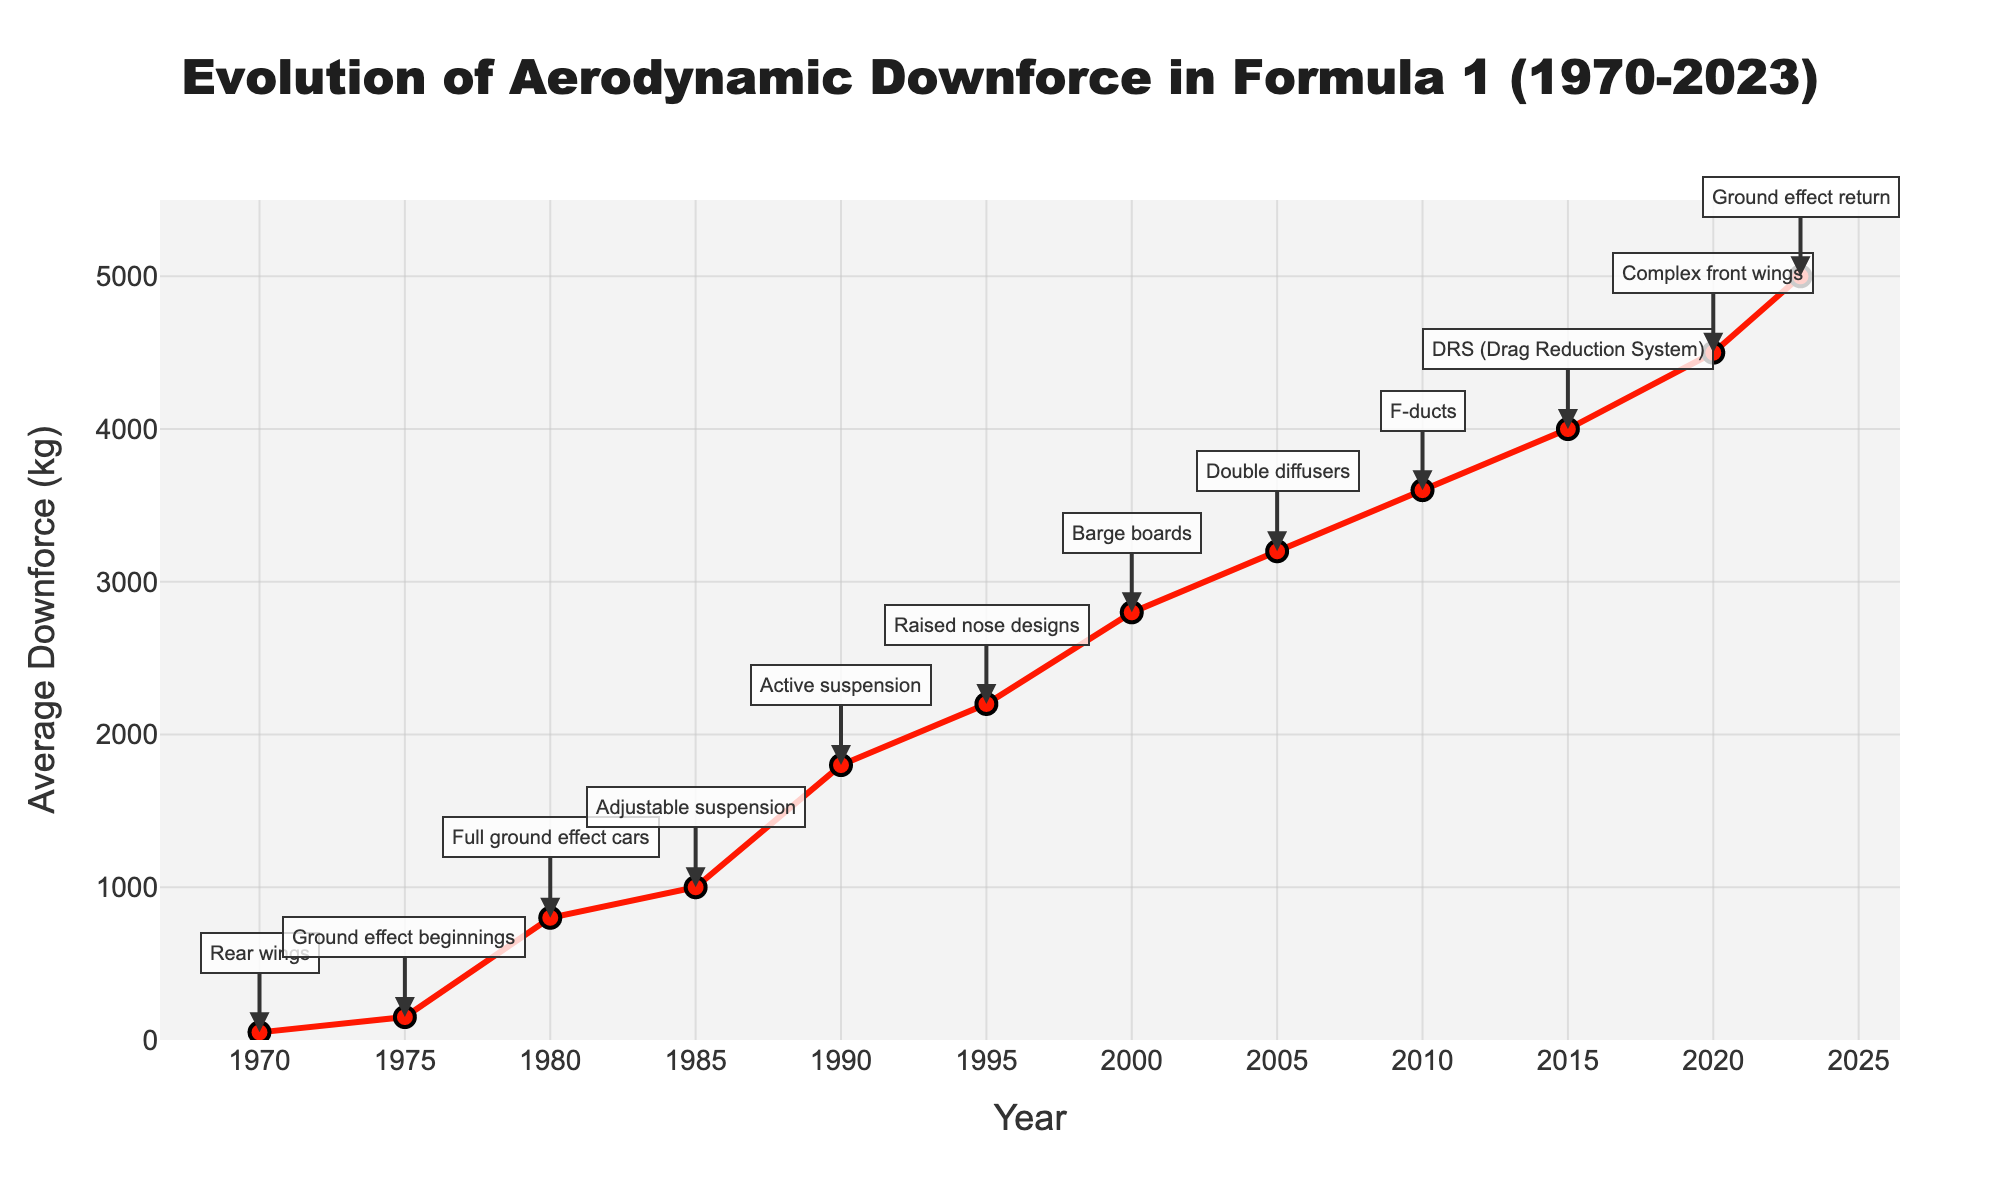What year did Formula 1 cars first see a significant increase in average downforce? From the chart, there is a noticeable jump in average downforce between 1975 and 1980, with 1980 showing a marked increase.
Answer: 1980 What is the difference in average downforce between the years 1980 and 2020? The average downforce in 1980 is 800 kg, and in 2020, it is 4500 kg. The difference is 4500 - 800 = 3700 kg.
Answer: 3700 kg Which year introduced the innovation "DRS (Drag Reduction System)" and what was the average downforce at that time? The chart annotates that DRS was introduced in 2015, and the corresponding average downforce is 4000 kg.
Answer: 2015, 4000 kg From 1990 to 2000, by how much did the average downforce increase? The average downforce in 1990 is 1800 kg and in 2000 it is 2800 kg. The increase is 2800 - 1800 = 1000 kg.
Answer: 1000 kg Between which two consecutive years did the average downforce experience the largest increase? By observing the chart, the largest increase between consecutive years is from 2005 to 2010, where it increased from 3200 kg to 3600 kg.
Answer: 2005 to 2010 How did the average downforce change between the introduction of "Adjustable suspension" and "Active suspension"? Adjustable suspension was introduced in 1985, with an average downforce of 1000 kg. Active suspension was introduced in 1990, with an average downforce of 1800 kg. The change is 1800 - 1000 = 800 kg.
Answer: Increased by 800 kg Which innovation marked the beginning of a sharp increase in downforce around the mid-70s? The innovation noted in the mid-70s with a sharp increase in downforce is "Ground effect beginnings" around 1975.
Answer: Ground effect beginnings What was the average downforce of F1 cars when "Rear wings" were introduced and how much did it increase by the next notable innovation in 1975? Rear wings were introduced in 1970 with an average downforce of 50 kg. By 1975, the downforce increased to 150 kg. The increase is 150 - 50 = 100 kg.
Answer: 100 kg Which year marked the return of "Ground effect" and what impact did it have on the average downforce? The return of ground effects is marked in 2023 with an average downforce of 5000 kg. This shows an increase from the previous year, 2020, which had 4500 kg, leading to an increase of 500 kg.
Answer: 2023, 500 kg In terms of visual attributes, which innovation annotation appears right before the year with the highest downforce? The annotation "Complex front wings" in 2020 appears right before the highest downforce year of 2023.
Answer: Complex front wings 